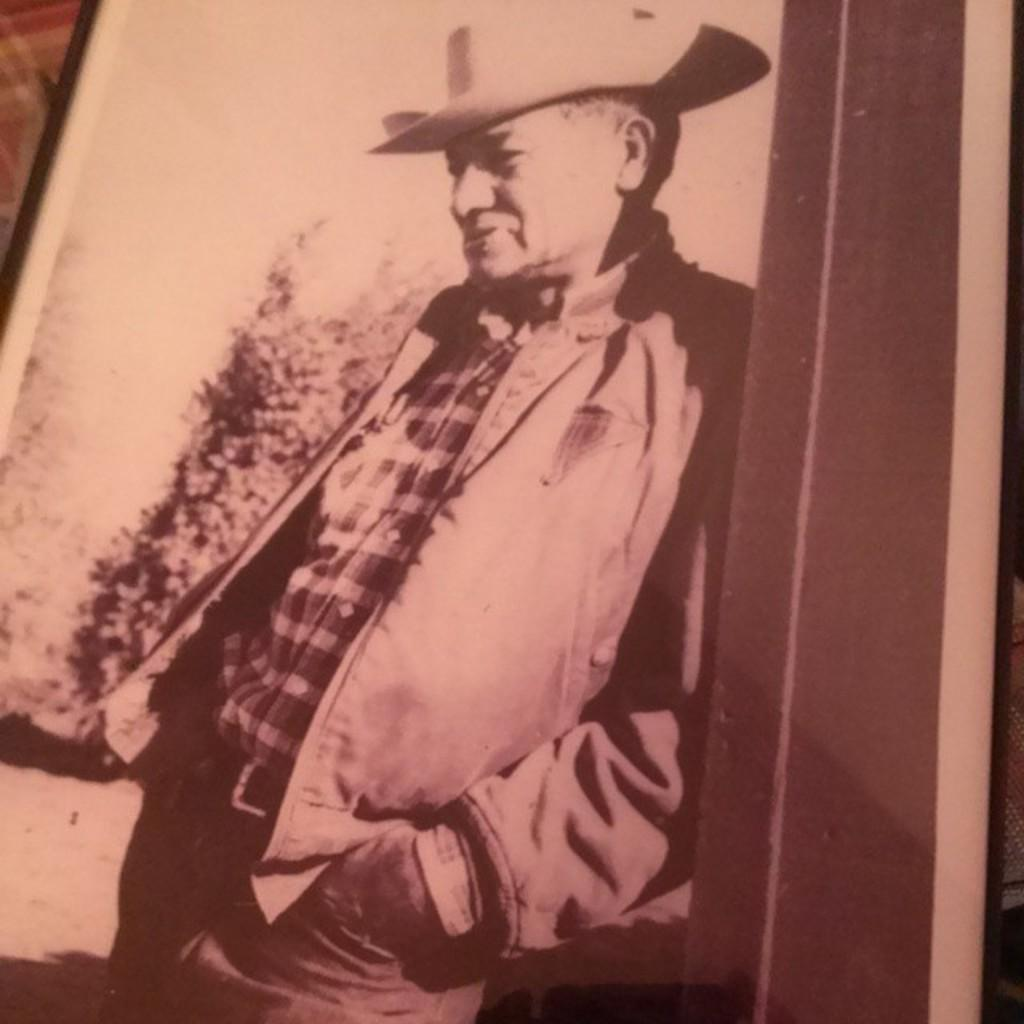What object in the image resembles a photo frame? There is an object that resembles a photo frame in the image. What is displayed within the photo frame? The photo frame contains an image of a person. Can you describe the person in the photo? The person in the photo is wearing a hat. What can be seen in the background of the photo? There is a tree visible in the background of the photo. How many birds are perched on the hat of the person in the photo? There are no birds visible in the image, as it only features a photo frame with an image of a person wearing a hat and a tree in the background. 